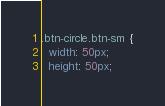Convert code to text. <code><loc_0><loc_0><loc_500><loc_500><_CSS_>.btn-circle.btn-sm {
  width: 50px;
  height: 50px;</code> 